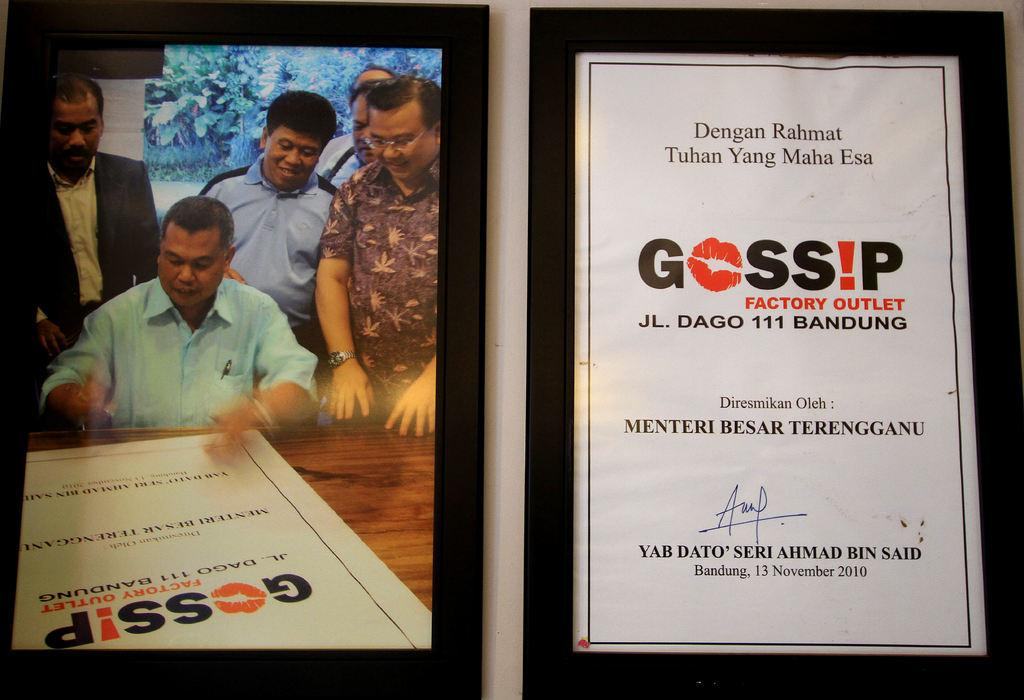<image>
Give a short and clear explanation of the subsequent image. Men are looking a flyer with "Gossip Factory Outlet" in print. 